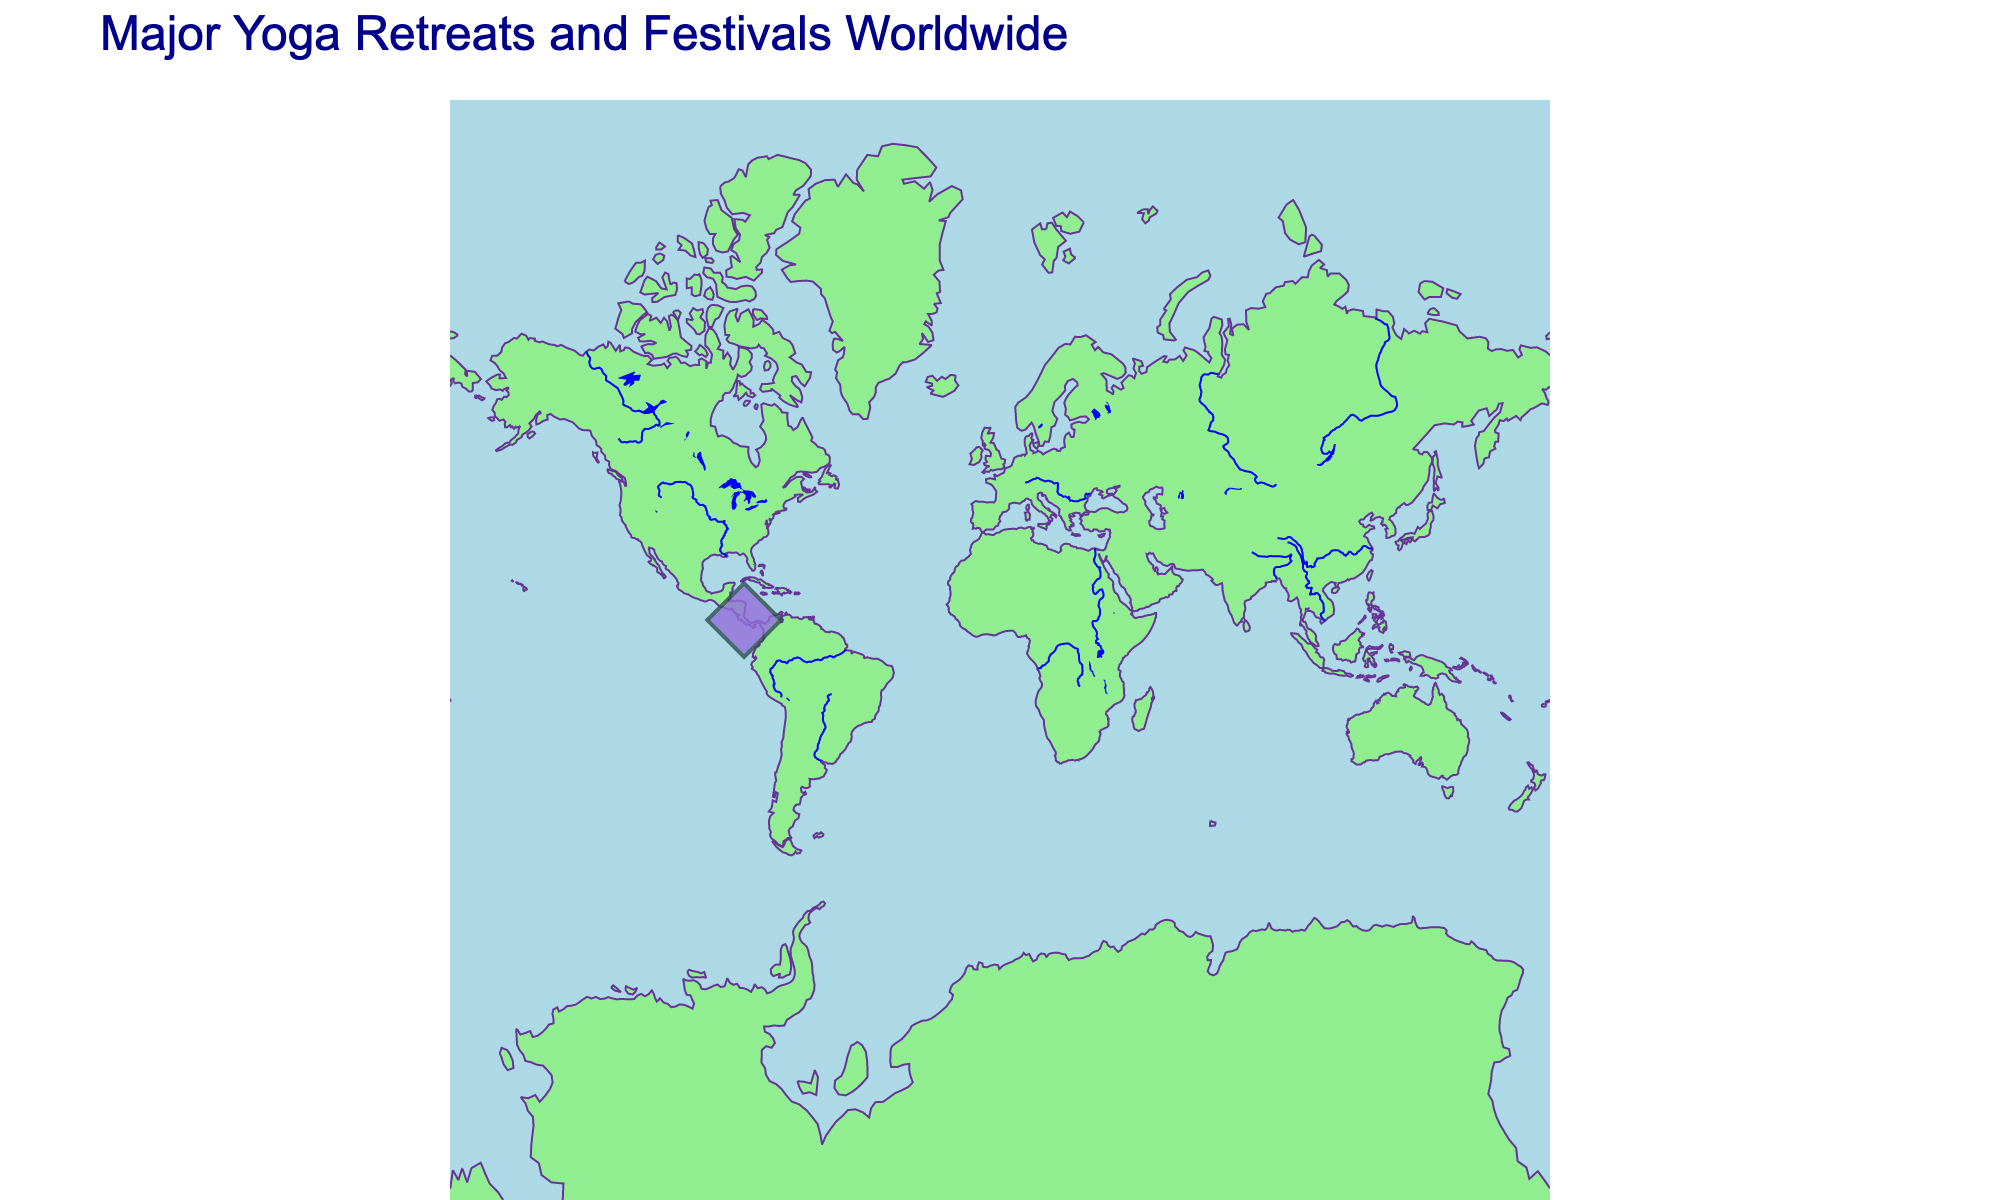How many locations are plotted on the figure? There is only one point plotted on the map. By counting the visible points, we can determine there is only one location.
Answer: One What is the title of the figure? The title of the figure is displayed at the top, reading "Major Yoga Retreats and Festivals Worldwide".
Answer: Major Yoga Retreats and Festivals Worldwide Which event has the largest attendance? Since there is only one event shown on the plot, it is the one with the largest attendance. Checking the data point reveals that "Envision Festival" has the largest attendance.
Answer: Envision Festival What is the attendance figure for the Envision Festival in Costa Rica? By hovering over the Costa Rica data point on the map, the attendance figure is revealed. It shows an attendance of 6000 for the Envision Festival.
Answer: 6000 Is the Envision Festival held closer to the equator or the poles? The latitude of Costa Rica is 9.7489, which is quite close to the equator compared to the poles.
Answer: Equator What is the symbol used to mark the events on the map? By inspecting the map visually, we can see that the events are marked with diamond symbols.
Answer: Diamond Are there any multiple data points overlapped in any location on the map? As there is only one data point visible on the map, there are no overlaps between multiple data points.
Answer: No What physical features are highlighted on the map alongside the locations of yoga retreats and festivals? The map shows coastlines, land, ocean, lakes, and rivers, each distinguished by different colors.
Answer: Coastlines, land, ocean, lakes, and rivers What colors are used to represent land and ocean on the map? The land is represented in LightGreen, and the ocean is represented in LightBlue.
Answer: LightGreen (land) and LightBlue (ocean) What continent is Costa Rica located on according to the map? By looking at the geographic coordinates and location on the map, Costa Rica is situated in Central America, which is part of the continent of North America.
Answer: North America 